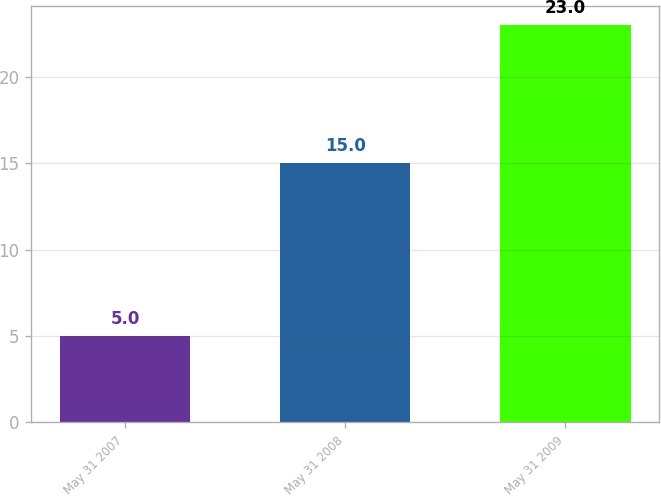Convert chart. <chart><loc_0><loc_0><loc_500><loc_500><bar_chart><fcel>May 31 2007<fcel>May 31 2008<fcel>May 31 2009<nl><fcel>5<fcel>15<fcel>23<nl></chart> 